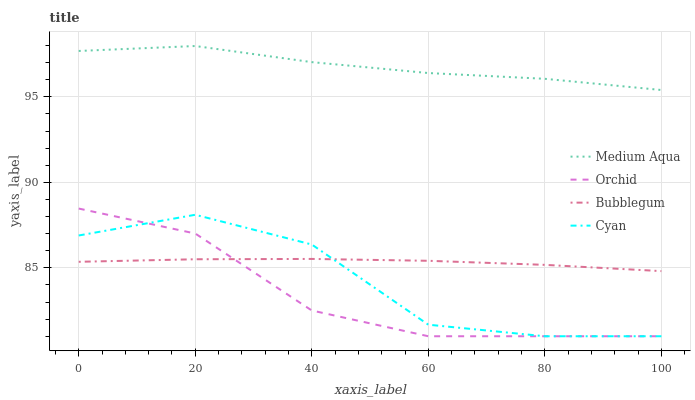Does Orchid have the minimum area under the curve?
Answer yes or no. Yes. Does Medium Aqua have the maximum area under the curve?
Answer yes or no. Yes. Does Bubblegum have the minimum area under the curve?
Answer yes or no. No. Does Bubblegum have the maximum area under the curve?
Answer yes or no. No. Is Bubblegum the smoothest?
Answer yes or no. Yes. Is Cyan the roughest?
Answer yes or no. Yes. Is Medium Aqua the smoothest?
Answer yes or no. No. Is Medium Aqua the roughest?
Answer yes or no. No. Does Cyan have the lowest value?
Answer yes or no. Yes. Does Bubblegum have the lowest value?
Answer yes or no. No. Does Medium Aqua have the highest value?
Answer yes or no. Yes. Does Bubblegum have the highest value?
Answer yes or no. No. Is Cyan less than Medium Aqua?
Answer yes or no. Yes. Is Medium Aqua greater than Cyan?
Answer yes or no. Yes. Does Bubblegum intersect Cyan?
Answer yes or no. Yes. Is Bubblegum less than Cyan?
Answer yes or no. No. Is Bubblegum greater than Cyan?
Answer yes or no. No. Does Cyan intersect Medium Aqua?
Answer yes or no. No. 